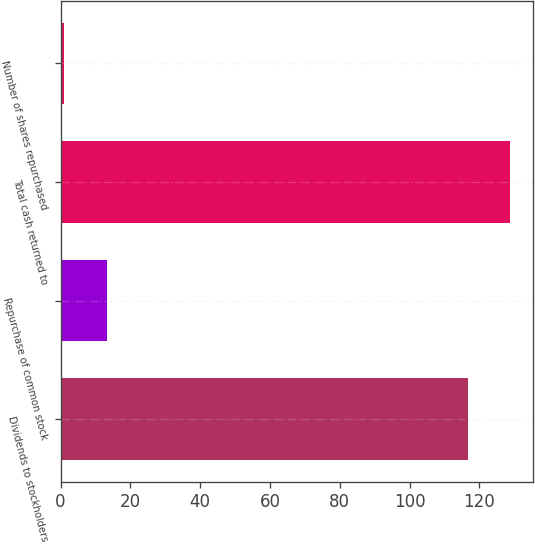Convert chart to OTSL. <chart><loc_0><loc_0><loc_500><loc_500><bar_chart><fcel>Dividends to stockholders<fcel>Repurchase of common stock<fcel>Total cash returned to<fcel>Number of shares repurchased<nl><fcel>116.7<fcel>13.21<fcel>128.91<fcel>1<nl></chart> 